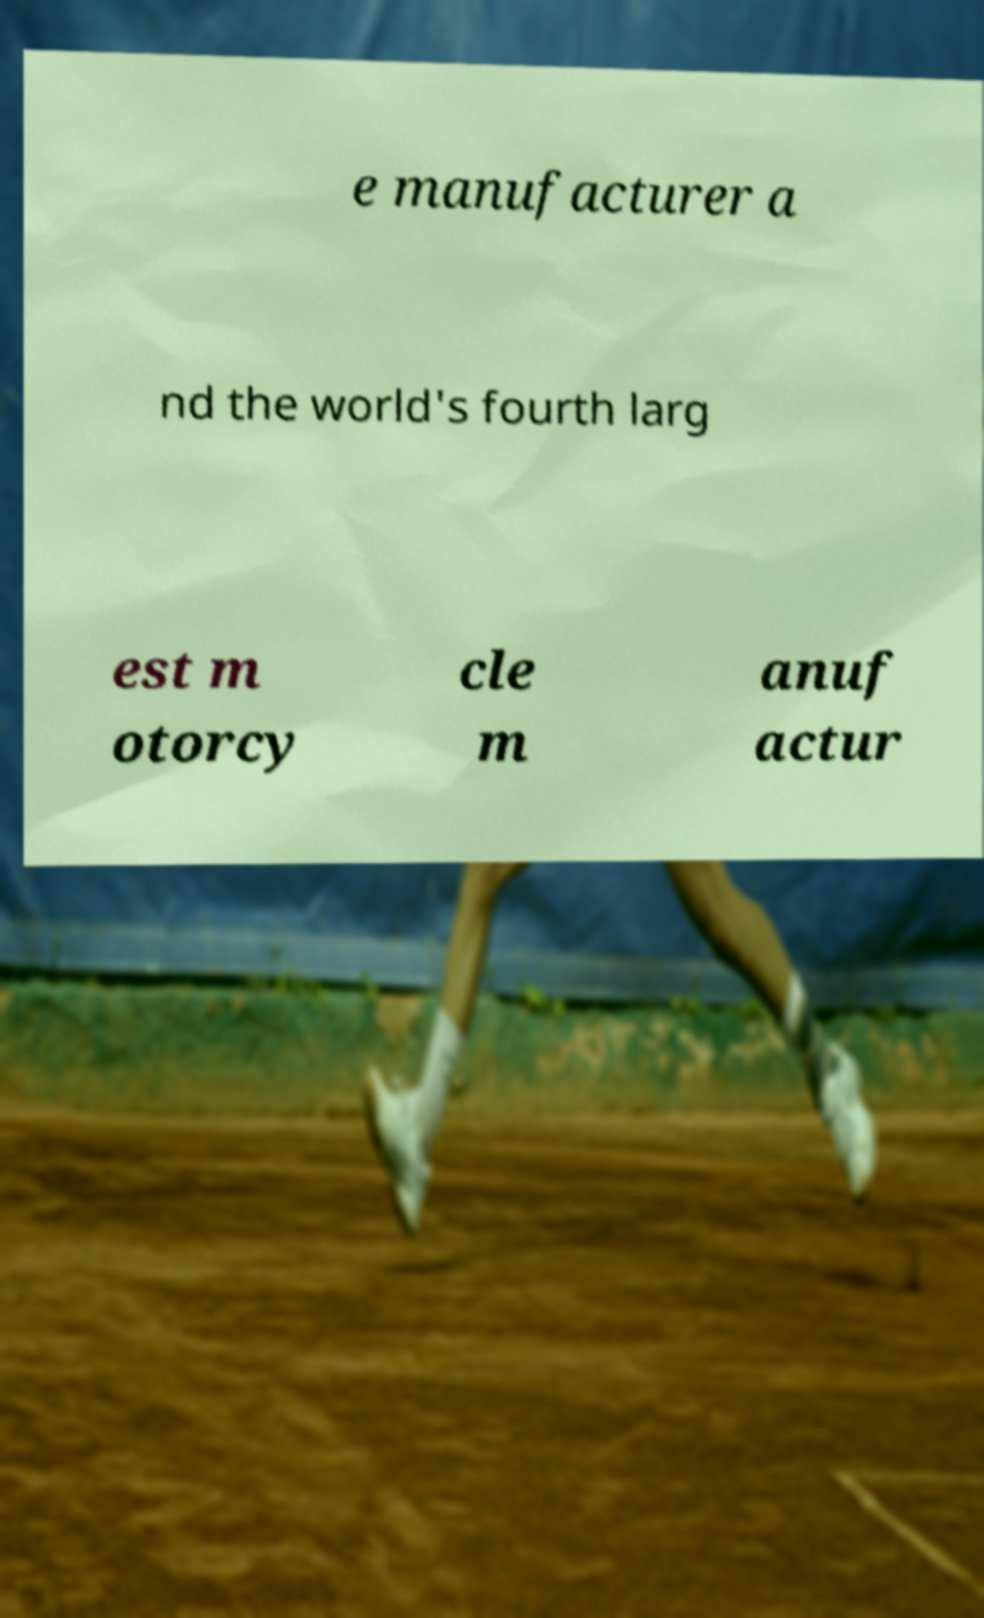For documentation purposes, I need the text within this image transcribed. Could you provide that? e manufacturer a nd the world's fourth larg est m otorcy cle m anuf actur 